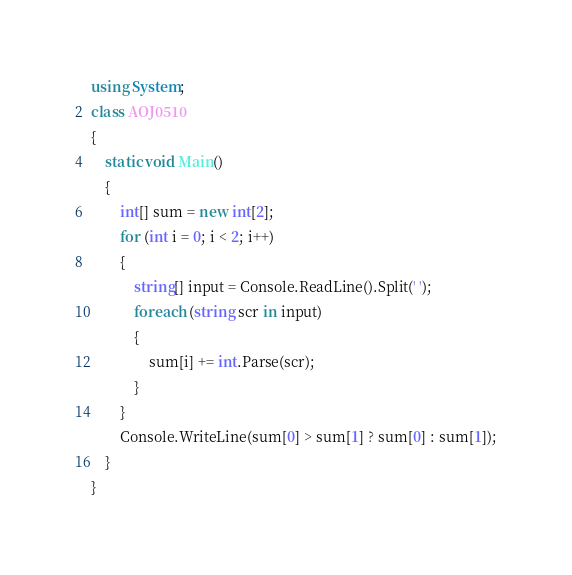Convert code to text. <code><loc_0><loc_0><loc_500><loc_500><_C#_>using System;
class AOJ0510
{
    static void Main()
    {
        int[] sum = new int[2];
        for (int i = 0; i < 2; i++)
        {
            string[] input = Console.ReadLine().Split(' ');
            foreach (string scr in input)
            {
                sum[i] += int.Parse(scr);
            }
        }
        Console.WriteLine(sum[0] > sum[1] ? sum[0] : sum[1]);
    }
}</code> 